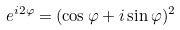<formula> <loc_0><loc_0><loc_500><loc_500>e ^ { i 2 \varphi } = ( \cos \varphi + i \sin \varphi ) ^ { 2 }</formula> 